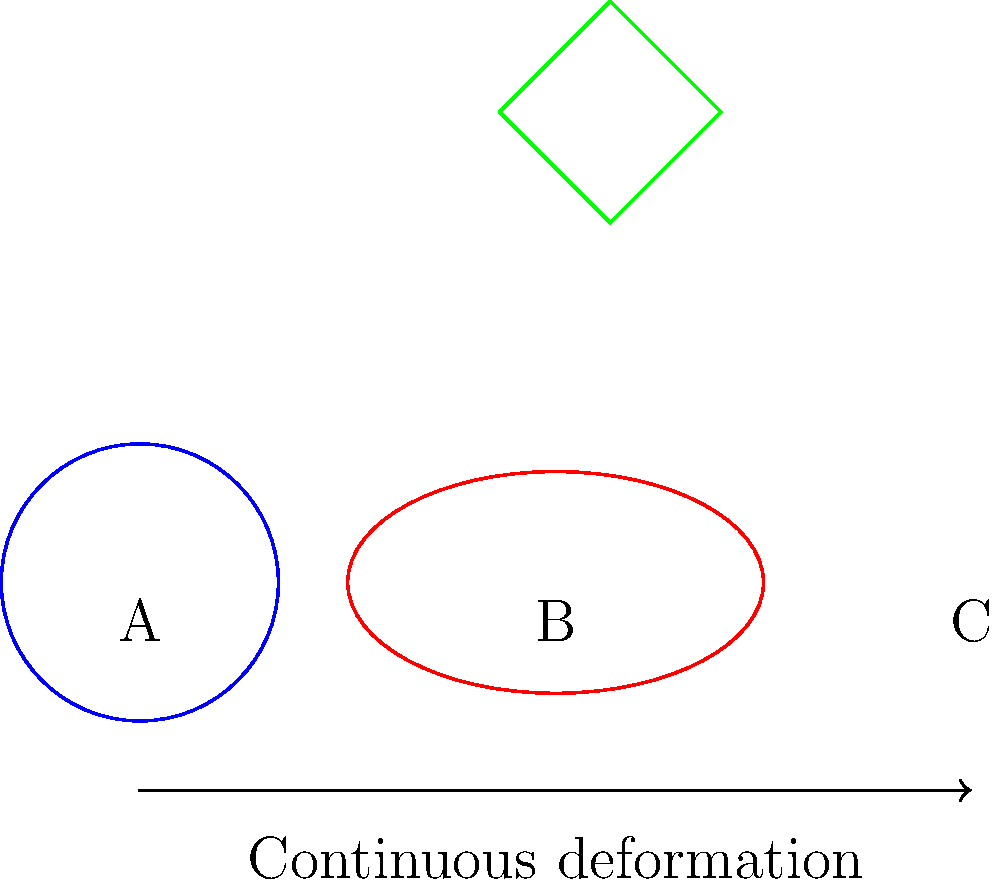Consider the continuous deformation of an album cover art from a circular shape (A) to an elliptical shape (B) and finally to a square shape (C). If the album cover art maintains its connectivity throughout the deformation process, which topological property remains invariant? To solve this problem, let's consider the topological properties of the shapes and how they change during continuous deformation:

1. Shape A (circle) has the following properties:
   - It is a simple closed curve
   - It has no holes

2. Shape B (ellipse) has the following properties:
   - It is also a simple closed curve
   - It has no holes

3. Shape C (square) has the following properties:
   - It is a simple closed curve
   - It has no holes

During the continuous deformation process:

a) The number of connected components remains constant (1 for all shapes).
b) The number of holes (genus) remains constant (0 for all shapes).
c) The Euler characteristic (χ = V - E + F) remains constant (χ = 2 for all shapes).

The key topological property that remains invariant throughout this deformation is the genus, which is the number of holes in the shape. In this case, the genus is 0 for all three shapes.

This invariance is guaranteed by the fact that continuous deformations (homeomorphisms) preserve topological properties. The deformation from a circle to an ellipse to a square does not create or destroy any holes, thus preserving the genus.
Answer: Genus 